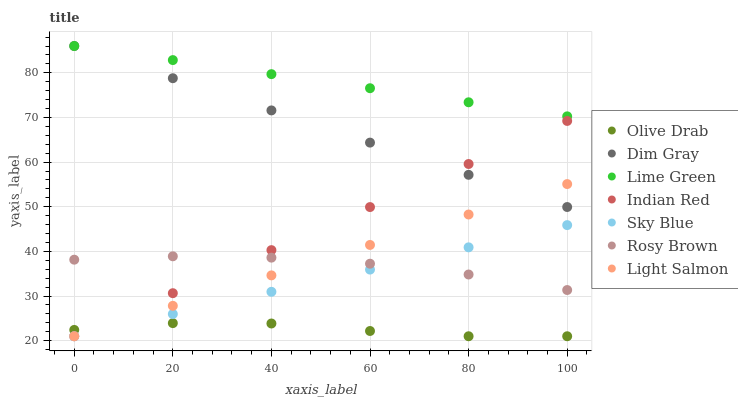Does Olive Drab have the minimum area under the curve?
Answer yes or no. Yes. Does Lime Green have the maximum area under the curve?
Answer yes or no. Yes. Does Dim Gray have the minimum area under the curve?
Answer yes or no. No. Does Dim Gray have the maximum area under the curve?
Answer yes or no. No. Is Light Salmon the smoothest?
Answer yes or no. Yes. Is Olive Drab the roughest?
Answer yes or no. Yes. Is Dim Gray the smoothest?
Answer yes or no. No. Is Dim Gray the roughest?
Answer yes or no. No. Does Light Salmon have the lowest value?
Answer yes or no. Yes. Does Dim Gray have the lowest value?
Answer yes or no. No. Does Lime Green have the highest value?
Answer yes or no. Yes. Does Rosy Brown have the highest value?
Answer yes or no. No. Is Indian Red less than Lime Green?
Answer yes or no. Yes. Is Lime Green greater than Sky Blue?
Answer yes or no. Yes. Does Sky Blue intersect Olive Drab?
Answer yes or no. Yes. Is Sky Blue less than Olive Drab?
Answer yes or no. No. Is Sky Blue greater than Olive Drab?
Answer yes or no. No. Does Indian Red intersect Lime Green?
Answer yes or no. No. 